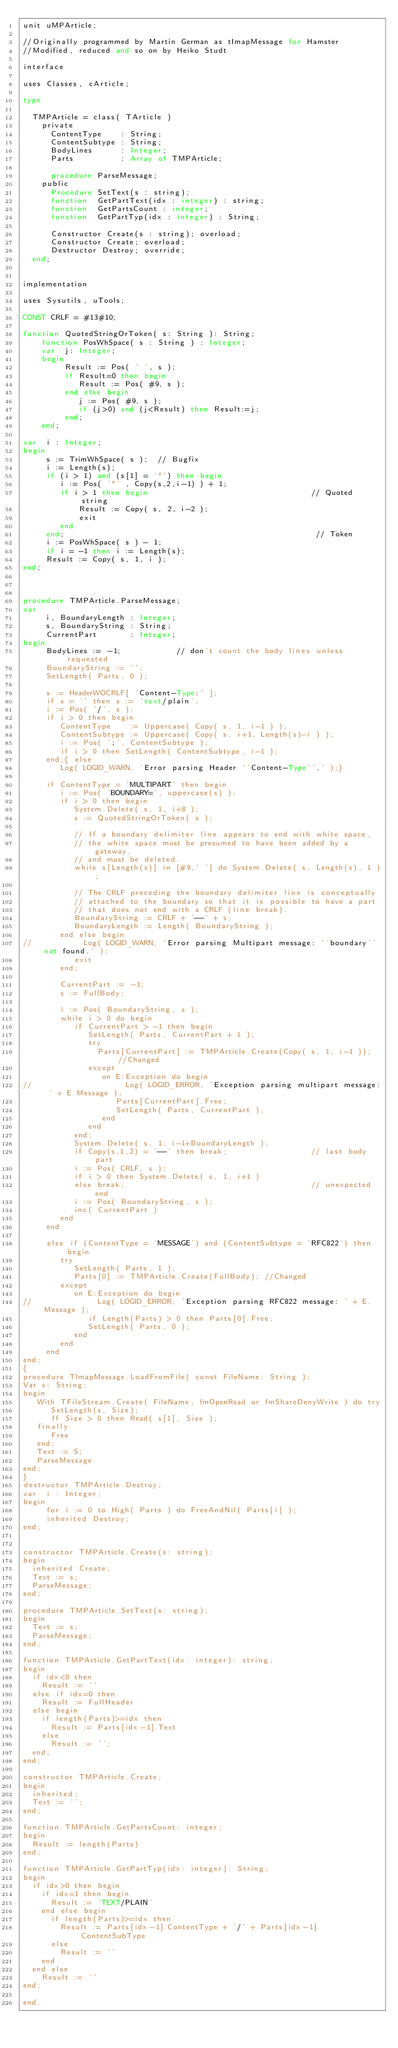<code> <loc_0><loc_0><loc_500><loc_500><_Pascal_>unit uMPArticle;

//Originally programmed by Martin German as tImapMessage for Hamster
//Modified, reduced and so on by Heiko Studt

interface

uses Classes, cArticle;

type

  TMPArticle = class( TArticle )
    private
      ContentType    : String;
      ContentSubtype : String;
      BodyLines      : Integer;
      Parts          : Array of TMPArticle;

      procedure ParseMessage;
    public
      Procedure SetText(s : string);
      function  GetPartText(idx : integer) : string;
      function  GetPartsCount : integer;
      function  GetPartTyp(idx : integer) : String;

      Constructor Create(s : string); overload;
      Constructor Create; overload;
      Destructor Destroy; override;
  end;


implementation

uses Sysutils, uTools;

CONST CRLF = #13#10;

function QuotedStringOrToken( s: String ): String;
    function PosWhSpace( s : String ) : Integer;
    var  j: Integer;
    begin
         Result := Pos( ' ', s );
         if Result=0 then begin
            Result := Pos( #9, s );
         end else begin
            j := Pos( #9, s );
            if (j>0) and (j<Result) then Result:=j;
         end;
    end;

var  i : Integer;
begin
     s := TrimWhSpace( s );  // Bugfix
     i := Length(s);
     if (i > 1) and (s[1] = '"') then begin
        i := Pos( '"' , Copy(s,2,i-1) ) + 1;
        if i > 1 then begin                                   // Quoted string
            Result := Copy( s, 2, i-2 );
            exit
        end
     end;                                                      // Token
     i := PosWhSpace( s ) - 1;
     if i = -1 then i := Length(s);
     Result := Copy( s, 1, i );
end;



procedure TMPArticle.ParseMessage;
var
     i, BoundaryLength : Integer;
     s, BoundaryString : String;
     CurrentPart       : Integer;
begin
     BodyLines := -1;            // don't count the body lines unless requested
     BoundaryString := '';
     SetLength( Parts, 0 );

     s := HeaderWOCRLF[ 'Content-Type:' ];
     if s = '' then s := 'text/plain';
     i := Pos( '/', s );
     if i > 0 then begin
        ContentType    := Uppercase( Copy( s, 1, i-1 ) );
        ContentSubtype := Uppercase( Copy( s, i+1, Length(s)-i ) );
        i := Pos( ';', ContentSubtype );
        if i > 0 then SetLength( ContentSubtype, i-1 );
     end;{ else
        Log( LOGID_WARN, 'Error parsing Header ''Content-Type''.' );}

     if ContentType = 'MULTIPART' then begin
        i := Pos( 'BOUNDARY=', uppercase(s) );
        if i > 0 then begin
           System.Delete( s, 1, i+8 );
           s := QuotedStringOrToken( s );

           // If a boundary delimiter line appears to end with white space,
           // the white space must be presumed to have been added by a gateway,
           // and must be deleted.
           while s[Length(s)] in [#9,' '] do System.Delete( s, Length(s), 1 );

           // The CRLF preceding the boundary delimiter line is conceptually
           // attached to the boundary so that it is possible to have a part
           // that does not end with a CRLF (line break).
           BoundaryString := CRLF + '--' + s;
           BoundaryLength := Length( BoundaryString );
        end else begin
//           Log( LOGID_WARN, 'Error parsing Multipart message: ''boundary'' not found.' );
           exit
        end;

        CurrentPart := -1;
        s := FullBody;

        i := Pos( BoundaryString, s );
        while i > 0 do begin
           if CurrentPart > -1 then begin
              SetLength( Parts, CurrentPart + 1 );
              try
                Parts[CurrentPart] := TMPArticle.Create(Copy( s, 1, i-1 )); //Changed
              except
                 on E:Exception do begin
//                    Log( LOGID_ERROR, 'Exception parsing multipart message: ' + E.Message );
                    Parts[CurrentPart].Free;
                    SetLength( Parts, CurrentPart );
                 end
              end
           end;
           System.Delete( s, 1, i-1+BoundaryLength );
           if Copy(s,1,2) = '--' then break;                  // last body part
           i := Pos( CRLF, s );
           if i > 0 then System.Delete( s, 1, i+1 )
           else break;                                        // unexpected end
           i := Pos( BoundaryString, s );
           inc( CurrentPart )
        end
     end

     else if (ContentType = 'MESSAGE') and (ContentSubtype = 'RFC822') then begin
        try
           SetLength( Parts, 1 );
           Parts[0] := TMPArticle.Create(FullBody); //Changed
        except
           on E:Exception do begin
//              Log( LOGID_ERROR, 'Exception parsing RFC822 message: ' + E.Message );
              if Length(Parts) > 0 then Parts[0].Free;
              SetLength( Parts, 0 );
           end
        end
     end
end;
{
procedure TImapMessage.LoadFromFile( const FileName: String );
Var s: String;
begin
   With TFileStream.Create( FileName, fmOpenRead or fmShareDenyWrite ) do try
      SetLength(s, Size);
      If Size > 0 then Read( s[1], Size );
   finally
      Free
   end;
   Text := S;
   ParseMessage
end;
}
destructor TMPArticle.Destroy;
var  i : Integer;
begin
     for i := 0 to High( Parts ) do FreeAndNil( Parts[i] );
     inherited Destroy;
end;


constructor TMPArticle.Create(s: string);
begin
  inherited Create;
  Text := s;
  ParseMessage;
end;

procedure TMPArticle.SetText(s: string);
begin
  Text := s;
  ParseMessage;
end;

function TMPArticle.GetPartText(idx: integer): string;
begin
  if idx<0 then
    Result := ''
  else if idx=0 then
    Result := FullHeader
  else begin
    if length(Parts)>=idx then
      Result := Parts[idx-1].Text
    else
      Result := '';
  end;
end;

constructor TMPArticle.Create;
begin
  inherited;
  Text := '';
end;

function TMPArticle.GetPartsCount: integer;
begin
  Result := length(Parts)
end;

function TMPArticle.GetPartTyp(idx: integer): String;
begin
  if idx>0 then begin
    if idx=1 then begin
      Result := 'TEXT/PLAIN'
    end else begin
      if length(Parts)>=idx then
        Result := Parts[idx-1].ContentType + '/' + Parts[idx-1].ContentSubType 
      else
        Result := ''
    end
  end else
    Result := ''
end;

end.
</code> 